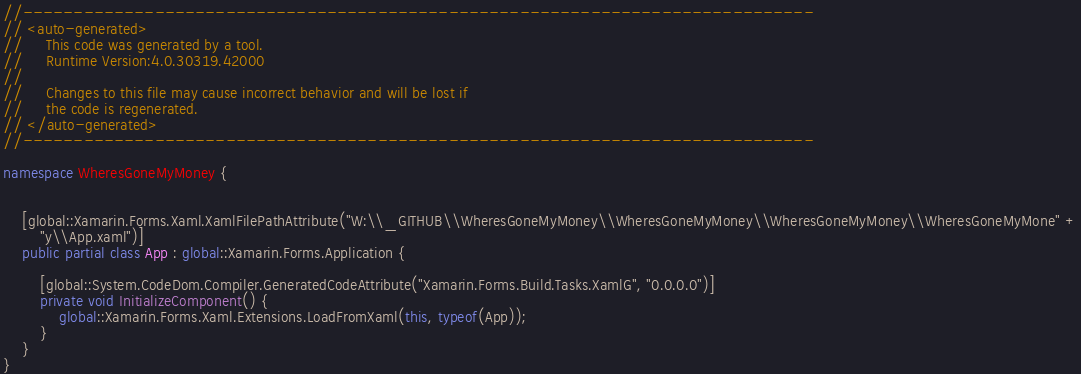Convert code to text. <code><loc_0><loc_0><loc_500><loc_500><_C#_>//------------------------------------------------------------------------------
// <auto-generated>
//     This code was generated by a tool.
//     Runtime Version:4.0.30319.42000
//
//     Changes to this file may cause incorrect behavior and will be lost if
//     the code is regenerated.
// </auto-generated>
//------------------------------------------------------------------------------

namespace WheresGoneMyMoney {
    
    
    [global::Xamarin.Forms.Xaml.XamlFilePathAttribute("W:\\_GITHUB\\WheresGoneMyMoney\\WheresGoneMyMoney\\WheresGoneMyMoney\\WheresGoneMyMone" +
        "y\\App.xaml")]
    public partial class App : global::Xamarin.Forms.Application {
        
        [global::System.CodeDom.Compiler.GeneratedCodeAttribute("Xamarin.Forms.Build.Tasks.XamlG", "0.0.0.0")]
        private void InitializeComponent() {
            global::Xamarin.Forms.Xaml.Extensions.LoadFromXaml(this, typeof(App));
        }
    }
}
</code> 